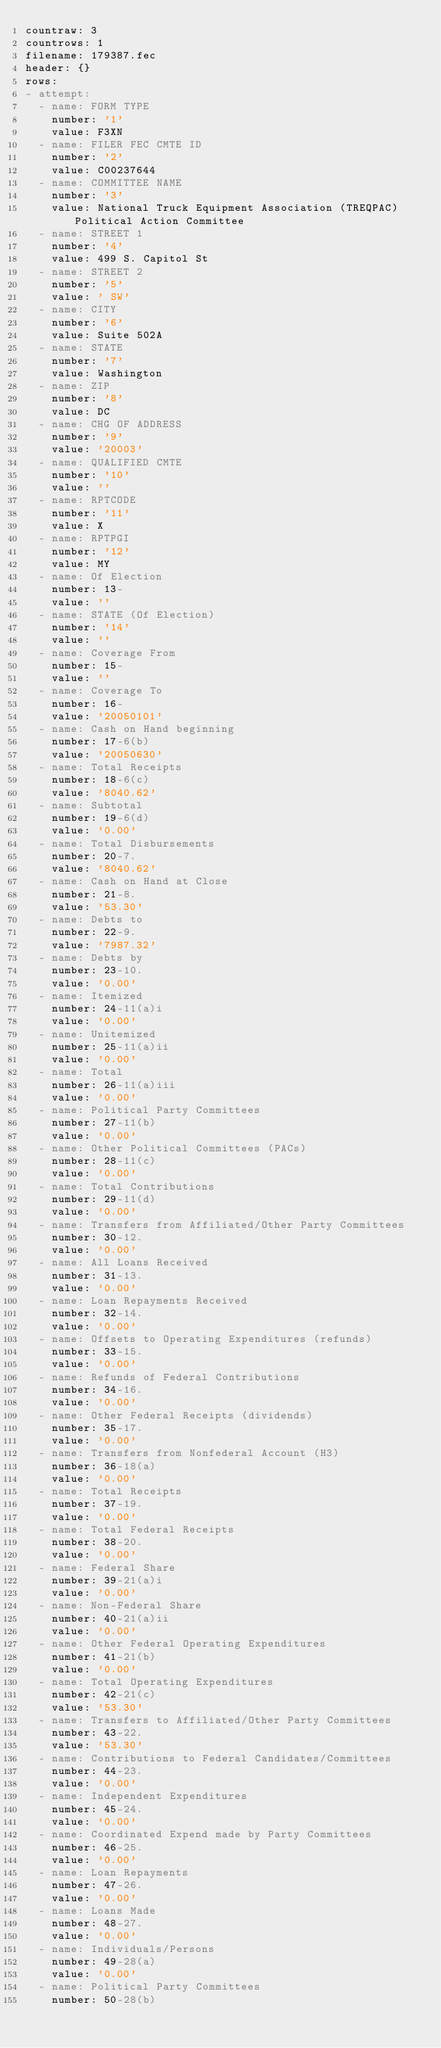Convert code to text. <code><loc_0><loc_0><loc_500><loc_500><_YAML_>countraw: 3
countrows: 1
filename: 179387.fec
header: {}
rows:
- attempt:
  - name: FORM TYPE
    number: '1'
    value: F3XN
  - name: FILER FEC CMTE ID
    number: '2'
    value: C00237644
  - name: COMMITTEE NAME
    number: '3'
    value: National Truck Equipment Association (TREQPAC) Political Action Committee
  - name: STREET 1
    number: '4'
    value: 499 S. Capitol St
  - name: STREET 2
    number: '5'
    value: ' SW'
  - name: CITY
    number: '6'
    value: Suite 502A
  - name: STATE
    number: '7'
    value: Washington
  - name: ZIP
    number: '8'
    value: DC
  - name: CHG OF ADDRESS
    number: '9'
    value: '20003'
  - name: QUALIFIED CMTE
    number: '10'
    value: ''
  - name: RPTCODE
    number: '11'
    value: X
  - name: RPTPGI
    number: '12'
    value: MY
  - name: Of Election
    number: 13-
    value: ''
  - name: STATE (Of Election)
    number: '14'
    value: ''
  - name: Coverage From
    number: 15-
    value: ''
  - name: Coverage To
    number: 16-
    value: '20050101'
  - name: Cash on Hand beginning
    number: 17-6(b)
    value: '20050630'
  - name: Total Receipts
    number: 18-6(c)
    value: '8040.62'
  - name: Subtotal
    number: 19-6(d)
    value: '0.00'
  - name: Total Disbursements
    number: 20-7.
    value: '8040.62'
  - name: Cash on Hand at Close
    number: 21-8.
    value: '53.30'
  - name: Debts to
    number: 22-9.
    value: '7987.32'
  - name: Debts by
    number: 23-10.
    value: '0.00'
  - name: Itemized
    number: 24-11(a)i
    value: '0.00'
  - name: Unitemized
    number: 25-11(a)ii
    value: '0.00'
  - name: Total
    number: 26-11(a)iii
    value: '0.00'
  - name: Political Party Committees
    number: 27-11(b)
    value: '0.00'
  - name: Other Political Committees (PACs)
    number: 28-11(c)
    value: '0.00'
  - name: Total Contributions
    number: 29-11(d)
    value: '0.00'
  - name: Transfers from Affiliated/Other Party Committees
    number: 30-12.
    value: '0.00'
  - name: All Loans Received
    number: 31-13.
    value: '0.00'
  - name: Loan Repayments Received
    number: 32-14.
    value: '0.00'
  - name: Offsets to Operating Expenditures (refunds)
    number: 33-15.
    value: '0.00'
  - name: Refunds of Federal Contributions
    number: 34-16.
    value: '0.00'
  - name: Other Federal Receipts (dividends)
    number: 35-17.
    value: '0.00'
  - name: Transfers from Nonfederal Account (H3)
    number: 36-18(a)
    value: '0.00'
  - name: Total Receipts
    number: 37-19.
    value: '0.00'
  - name: Total Federal Receipts
    number: 38-20.
    value: '0.00'
  - name: Federal Share
    number: 39-21(a)i
    value: '0.00'
  - name: Non-Federal Share
    number: 40-21(a)ii
    value: '0.00'
  - name: Other Federal Operating Expenditures
    number: 41-21(b)
    value: '0.00'
  - name: Total Operating Expenditures
    number: 42-21(c)
    value: '53.30'
  - name: Transfers to Affiliated/Other Party Committees
    number: 43-22.
    value: '53.30'
  - name: Contributions to Federal Candidates/Committees
    number: 44-23.
    value: '0.00'
  - name: Independent Expenditures
    number: 45-24.
    value: '0.00'
  - name: Coordinated Expend made by Party Committees
    number: 46-25.
    value: '0.00'
  - name: Loan Repayments
    number: 47-26.
    value: '0.00'
  - name: Loans Made
    number: 48-27.
    value: '0.00'
  - name: Individuals/Persons
    number: 49-28(a)
    value: '0.00'
  - name: Political Party Committees
    number: 50-28(b)</code> 